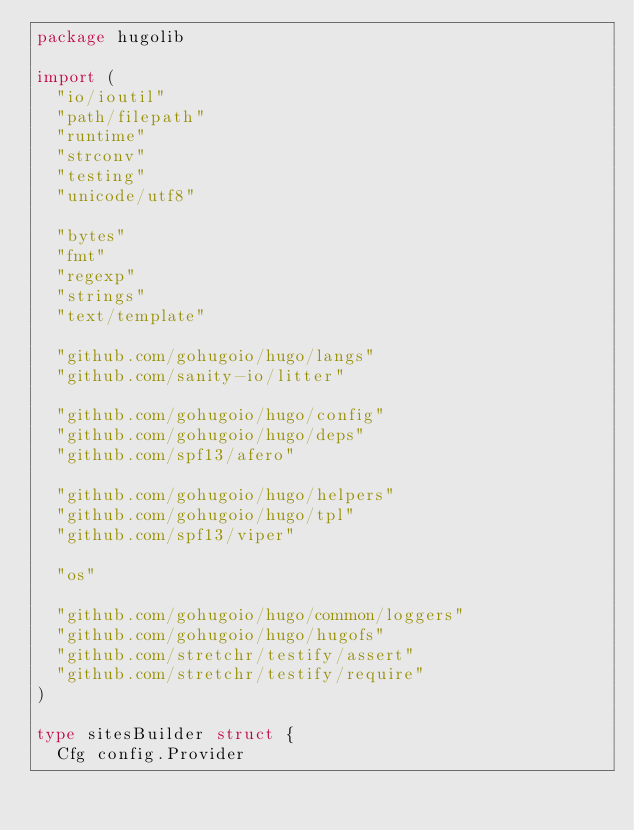<code> <loc_0><loc_0><loc_500><loc_500><_Go_>package hugolib

import (
	"io/ioutil"
	"path/filepath"
	"runtime"
	"strconv"
	"testing"
	"unicode/utf8"

	"bytes"
	"fmt"
	"regexp"
	"strings"
	"text/template"

	"github.com/gohugoio/hugo/langs"
	"github.com/sanity-io/litter"

	"github.com/gohugoio/hugo/config"
	"github.com/gohugoio/hugo/deps"
	"github.com/spf13/afero"

	"github.com/gohugoio/hugo/helpers"
	"github.com/gohugoio/hugo/tpl"
	"github.com/spf13/viper"

	"os"

	"github.com/gohugoio/hugo/common/loggers"
	"github.com/gohugoio/hugo/hugofs"
	"github.com/stretchr/testify/assert"
	"github.com/stretchr/testify/require"
)

type sitesBuilder struct {
	Cfg config.Provider</code> 